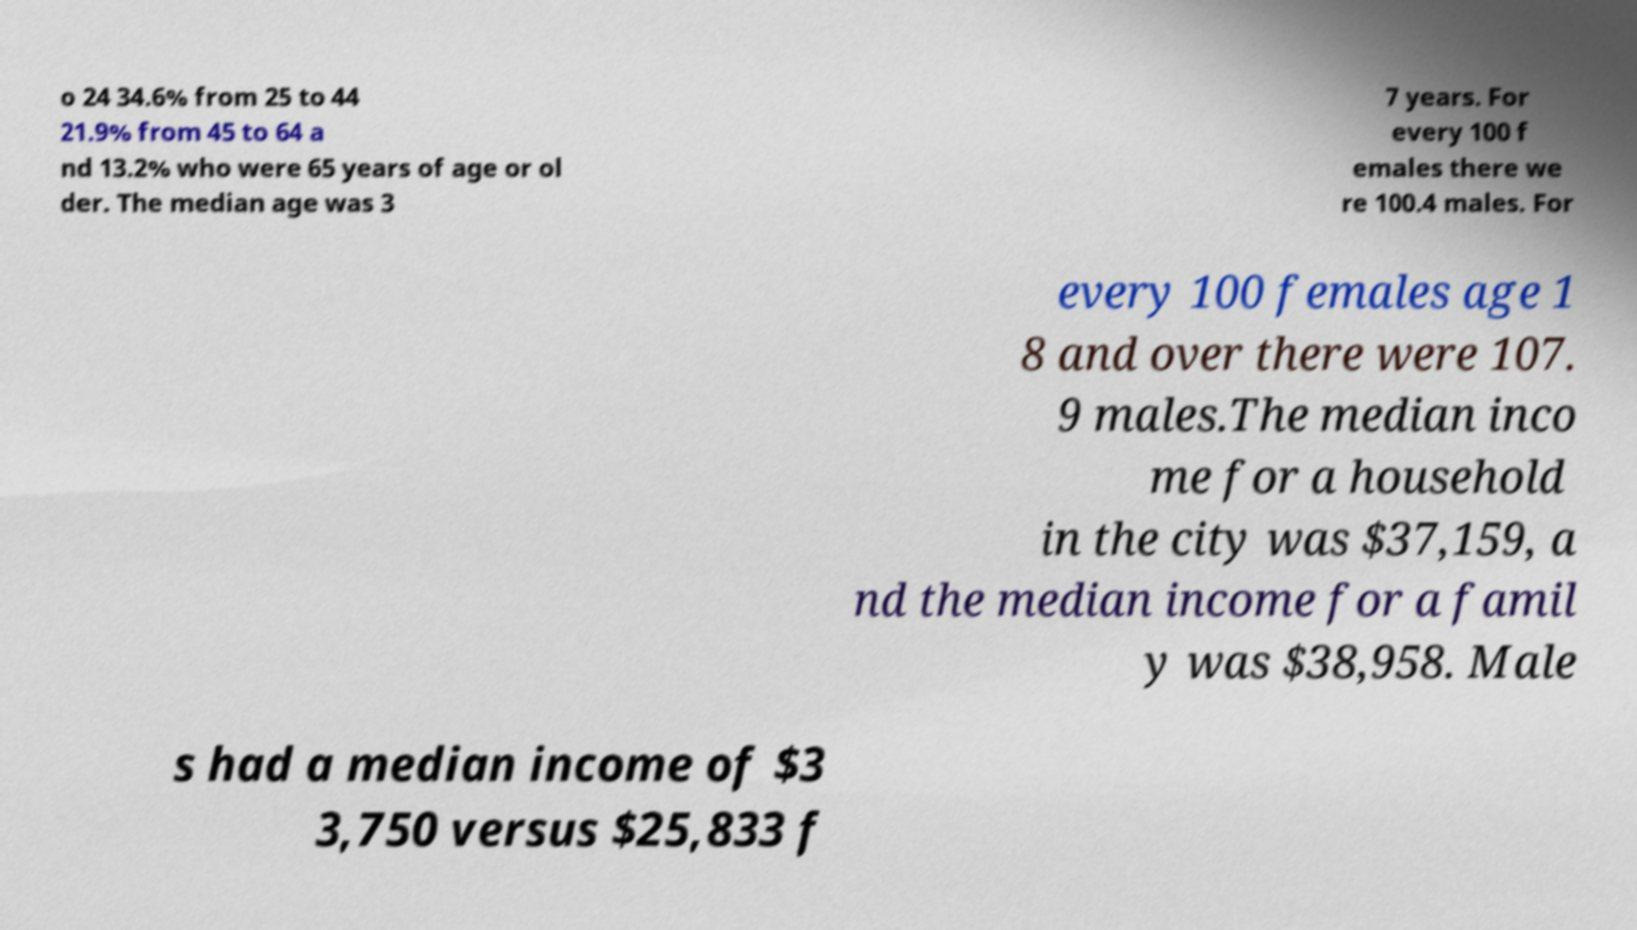Could you extract and type out the text from this image? o 24 34.6% from 25 to 44 21.9% from 45 to 64 a nd 13.2% who were 65 years of age or ol der. The median age was 3 7 years. For every 100 f emales there we re 100.4 males. For every 100 females age 1 8 and over there were 107. 9 males.The median inco me for a household in the city was $37,159, a nd the median income for a famil y was $38,958. Male s had a median income of $3 3,750 versus $25,833 f 